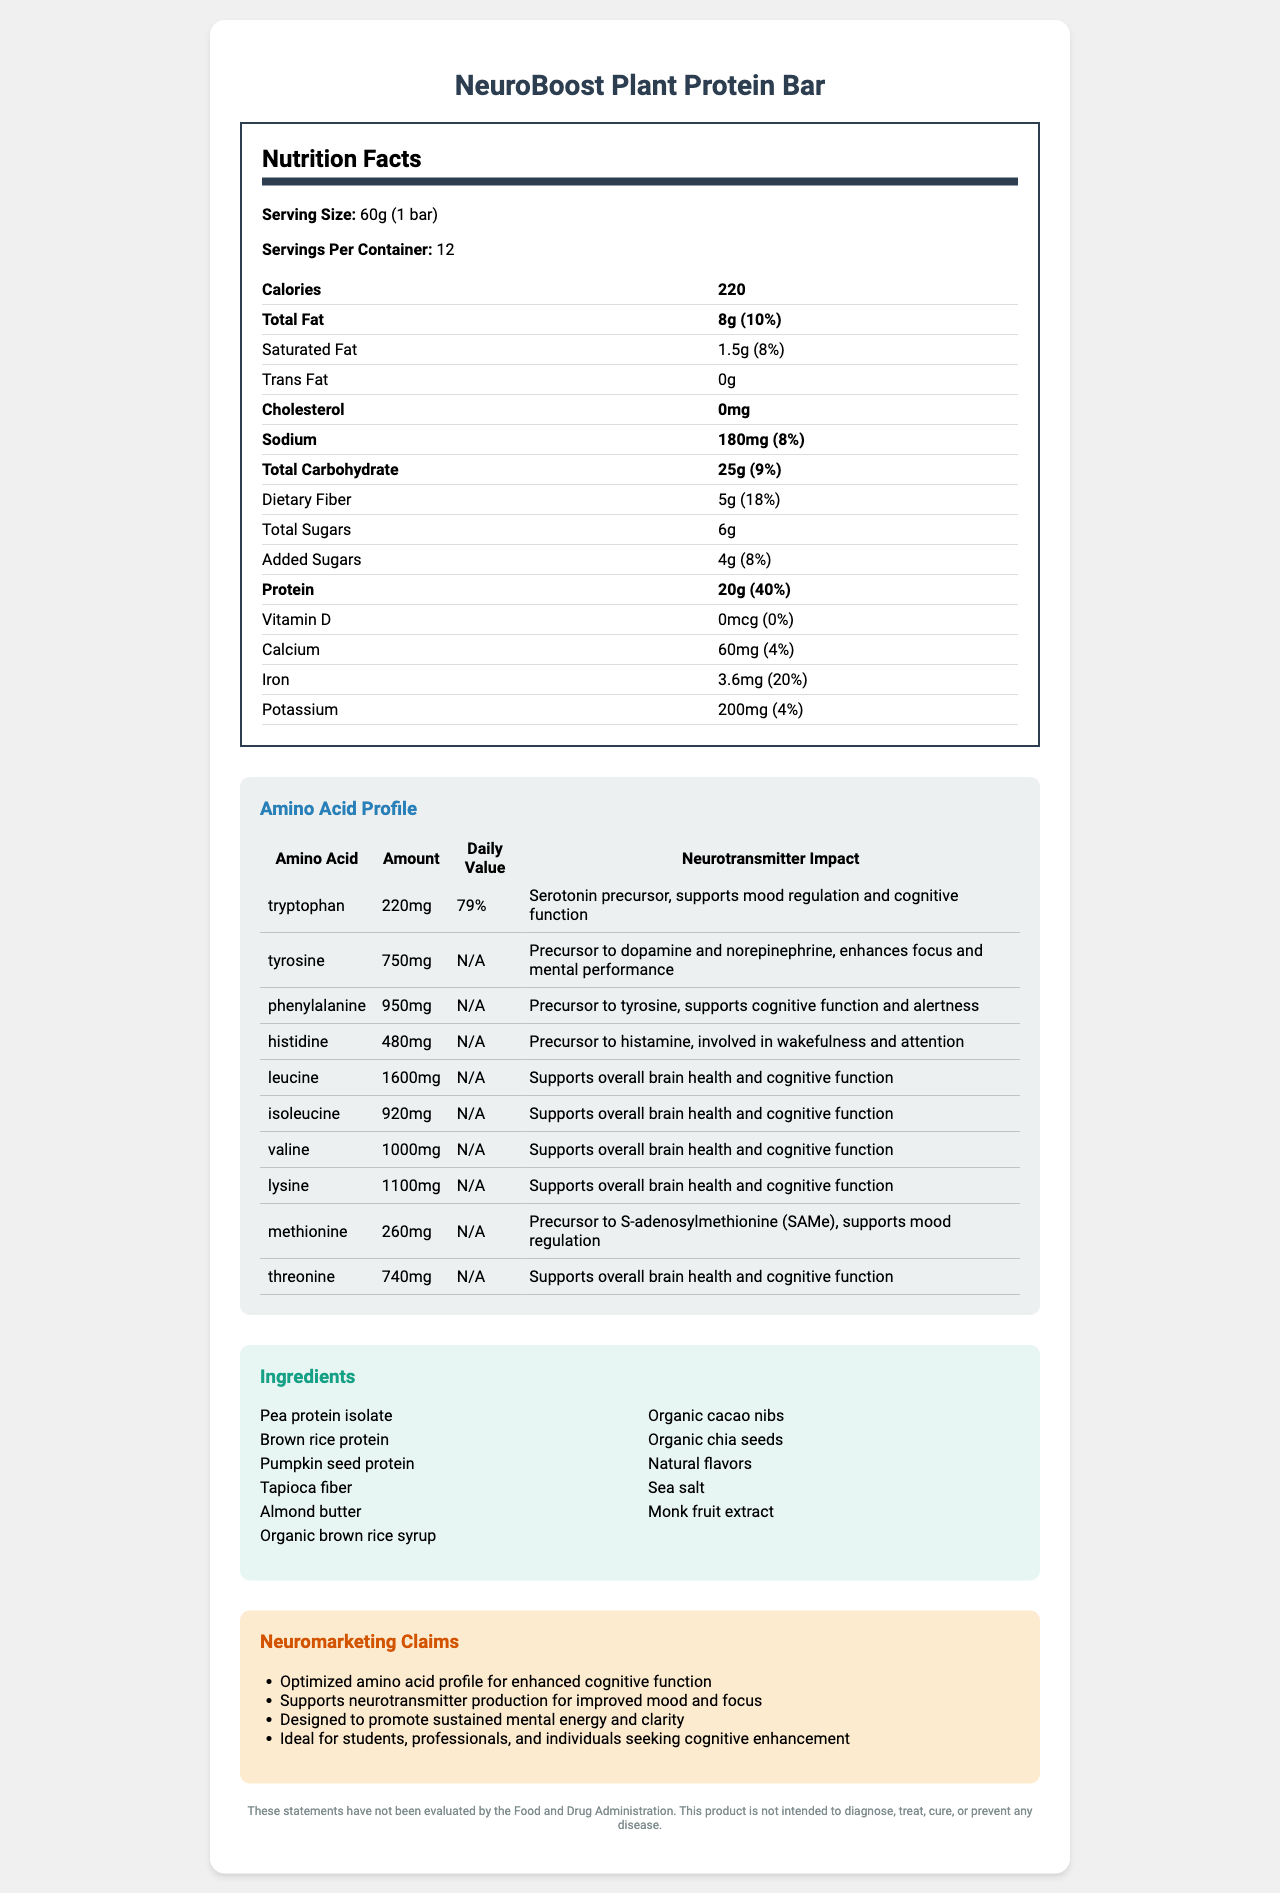what is the serving size for the NeuroBoost Plant Protein Bar? The serving size is clearly listed at the top of the nutrition facts section as 60g or 1 bar.
Answer: 60g (1 bar) how many calories are in one serving of the NeuroBoost Plant Protein Bar? The calories per serving are listed in the nutrition facts section at the top of the table.
Answer: 220 what is the total amount of protein in one serving? The amount of protein per serving is shown as 20g in the nutrition facts section.
Answer: 20g which amino acid in the NeuroBoost Plant Protein Bar is a precursor to serotonin? The amino acid profile indicates that tryptophan is a serotonin precursor and supports mood regulation and cognitive function.
Answer: Tryptophan what ingredients are used in the NeuroBoost Plant Protein Bar? The ingredients are listed in a dedicated section with bullet points.
Answer: Pea protein isolate, Brown rice protein, Pumpkin seed protein, Tapioca fiber, Almond butter, Organic brown rice syrup, Organic cacao nibs, Organic chia seeds, Natural flavors, Sea salt, Monk fruit extract how much iron is in one serving of the protein bar? The amount of iron per serving is specified in the nutrition facts section.
Answer: 3.6mg what is the function of tyrosine in neurotransmitter production? The amino acid profile states that tyrosine is a precursor to dopamine and norepinephrine and enhances focus and mental performance.
Answer: Precursor to dopamine and norepinephrine, enhances focus and mental performance how many grams of dietary fiber are in one serving of the protein bar? The amount of dietary fiber per serving is listed in the nutrition facts section as 5g.
Answer: 5g what is the total carbohydrate content per serving? The total carbohydrate content per serving is given in the nutrition facts section as 25g.
Answer: 25g which of the following amino acids has the highest amount per serving in the NeuroBoost Plant Protein Bar?
A. Leucine
B. Lysine
C. Tyrosine
D. Methionine The amino acid profile shows that leucine has the highest amount per serving at 1600mg.
Answer: A. Leucine what daily value percentage of total fat does one serving of this product provide?
A. 8%
B. 10%
C. 18%
D. 20% The nutrition facts section shows that the daily value percentage for total fat is 10%.
Answer: B. 10% does the NeuroBoost Plant Protein Bar contain any added sugars? The nutrition facts indicate that there are 4g of added sugars per serving.
Answer: Yes which amino acids support overall brain health and cognitive function? According to the amino acid profile, these amino acids support overall brain health and cognitive function.
Answer: Leucine, Isoleucine, Valine, Lysine, Threonine summarize the main idea of the document. The document is structured to present all relevant nutritional and functional information about the NeuroBoost Plant Protein Bar, with a focus on its benefits for cognitive and mental health.
Answer: The document provides a comprehensive overview of the nutrition facts for the NeuroBoost Plant Protein Bar, including detailed information on serving size, calories, macronutrients, vitamins, and minerals. It emphasizes the amino acid profile and its impact on neurotransmitter production, highlighting how specific amino acids like tryptophan, tyrosine, and phenylalanine contribute to cognitive function, mood regulation, and mental performance. The document also lists the ingredients, allergen information, and neuromarketing claims that position the product as beneficial for cognitive enhancement. A disclaimer notes that these claims have not been evaluated by the FDA. what is the exact amount of funding received for the development of NeuroBoost Plant Protein Bar? The document does not provide any information on funding received for the development of the product.
Answer: Not enough information 